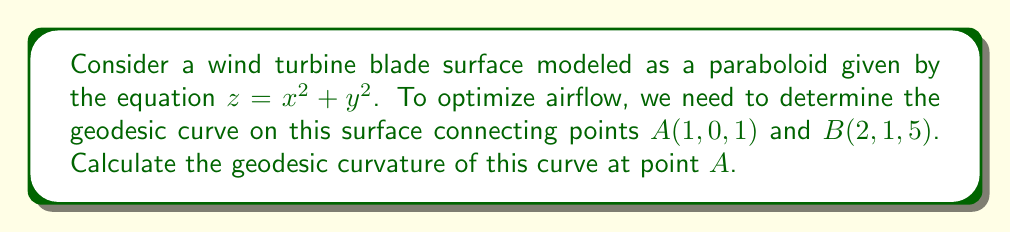Solve this math problem. To solve this problem, we'll follow these steps:

1) First, we need to parametrize the surface. Let's use the parametrization:
   $\mathbf{r}(u, v) = (u, v, u^2 + v^2)$

2) The metric tensor for this surface is:
   $$g = \begin{pmatrix}
   1 + 4u^2 & 4uv \\
   4uv & 1 + 4v^2
   \end{pmatrix}$$

3) The Christoffel symbols are:
   $$\Gamma^1_{11} = \frac{2u}{1+4u^2}, \Gamma^1_{12} = \Gamma^1_{21} = \frac{-2v}{1+4u^2}, \Gamma^1_{22} = \frac{2u}{1+4u^2}$$
   $$\Gamma^2_{11} = \frac{-2u}{1+4v^2}, \Gamma^2_{12} = \Gamma^2_{21} = \frac{2u}{1+4v^2}, \Gamma^2_{22} = \frac{2v}{1+4v^2}$$

4) The geodesic equations are:
   $$\frac{d^2u}{dt^2} + \Gamma^1_{11}(\frac{du}{dt})^2 + 2\Gamma^1_{12}\frac{du}{dt}\frac{dv}{dt} + \Gamma^1_{22}(\frac{dv}{dt})^2 = 0$$
   $$\frac{d^2v}{dt^2} + \Gamma^2_{11}(\frac{du}{dt})^2 + 2\Gamma^2_{12}\frac{du}{dt}\frac{dv}{dt} + \Gamma^2_{22}(\frac{dv}{dt})^2 = 0$$

5) At point $A(1, 0, 1)$, we have $u=1$ and $v=0$. The geodesic curvature at this point is given by:
   $$\kappa_g = \frac{|\frac{d^2v}{dt^2}\frac{du}{dt} - \frac{d^2u}{dt^2}\frac{dv}{dt}|}{((\frac{du}{dt})^2 + (\frac{dv}{dt})^2)^{3/2}}$$

6) To find $\frac{du}{dt}$ and $\frac{dv}{dt}$ at $A$, we can use the direction vector from $A$ to $B$:
   $\vec{AB} = (1, 1, 4)$
   So, $\frac{du}{dt} = 1$ and $\frac{dv}{dt} = 1$ at $A$.

7) Substituting into the geodesic equations at point $A$:
   $$\frac{d^2u}{dt^2} + \frac{2}{5}(1)^2 + 2(0)(1)(1) + \frac{2}{5}(1)^2 = 0$$
   $$\frac{d^2u}{dt^2} = -\frac{4}{5}$$

   $$\frac{d^2v}{dt^2} + \frac{-2}{1}(1)^2 + 2(\frac{2}{1})(1)(1) + 0 = 0$$
   $$\frac{d^2v}{dt^2} = -2$$

8) Now we can calculate the geodesic curvature:
   $$\kappa_g = \frac{|-2(1) - (-\frac{4}{5})(1)|}{((1)^2 + (1)^2)^{3/2}} = \frac{1.2}{2\sqrt{2}} = \frac{3\sqrt{2}}{10}$$
Answer: $\frac{3\sqrt{2}}{10}$ 